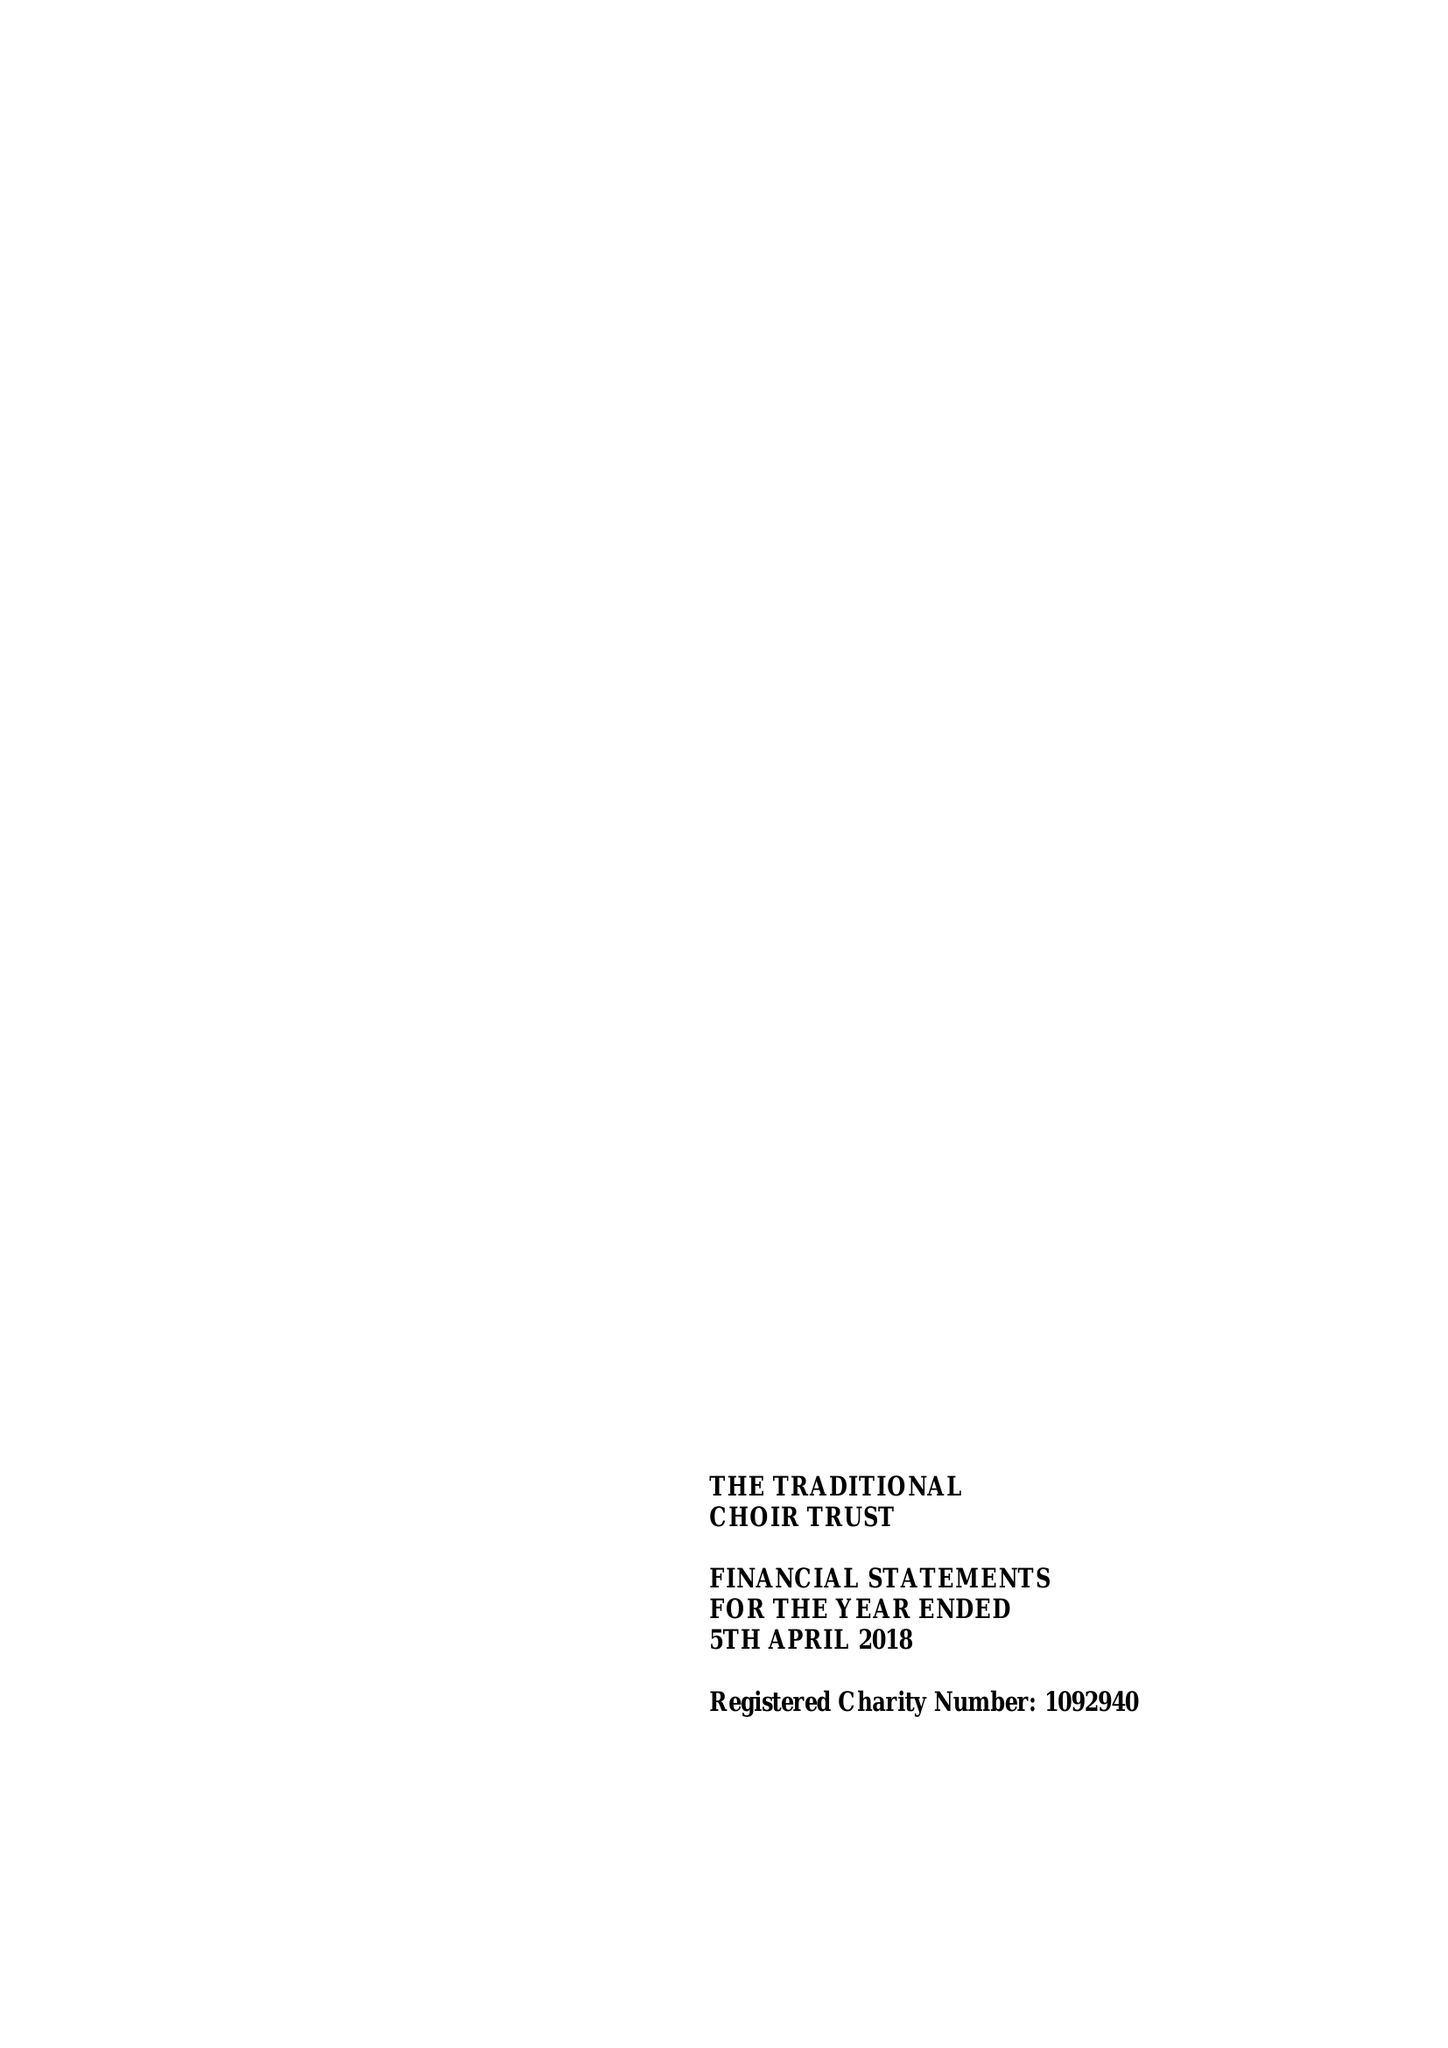What is the value for the income_annually_in_british_pounds?
Answer the question using a single word or phrase. 34084.00 